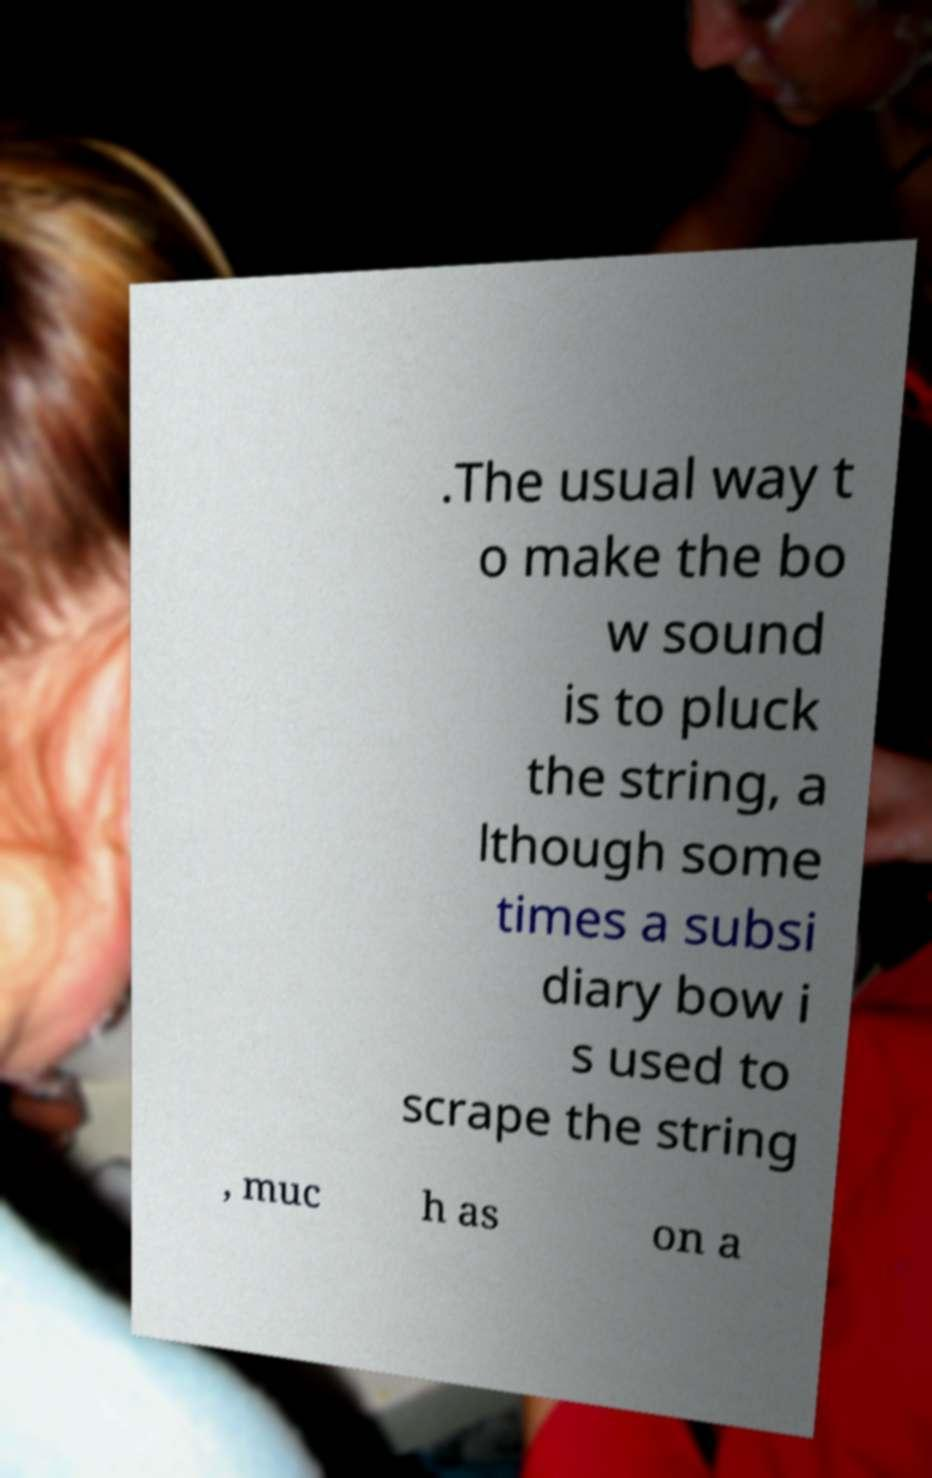Could you assist in decoding the text presented in this image and type it out clearly? .The usual way t o make the bo w sound is to pluck the string, a lthough some times a subsi diary bow i s used to scrape the string , muc h as on a 